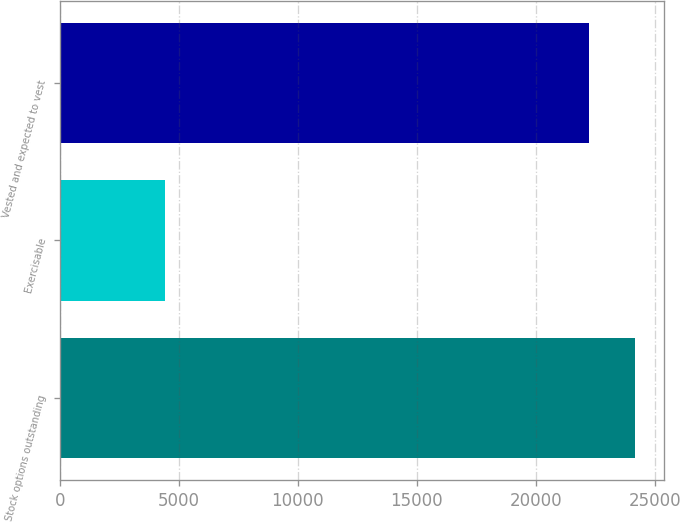Convert chart. <chart><loc_0><loc_0><loc_500><loc_500><bar_chart><fcel>Stock options outstanding<fcel>Exercisable<fcel>Vested and expected to vest<nl><fcel>24188.8<fcel>4420<fcel>22221<nl></chart> 